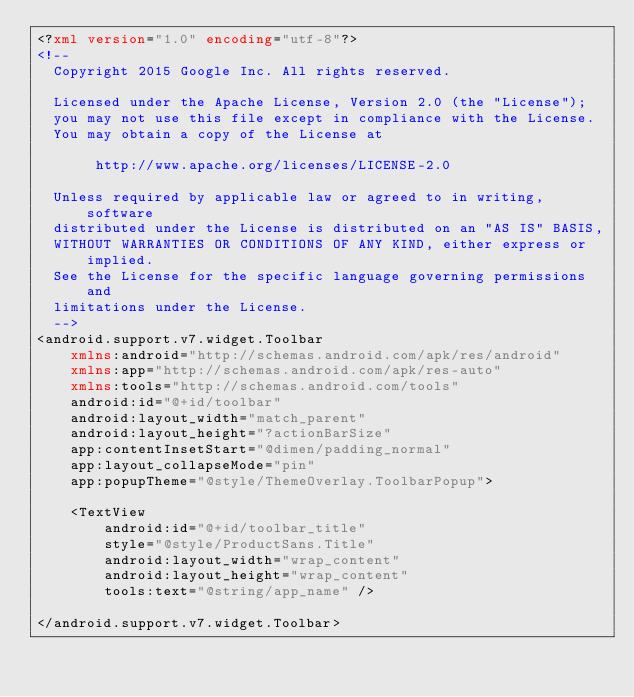Convert code to text. <code><loc_0><loc_0><loc_500><loc_500><_XML_><?xml version="1.0" encoding="utf-8"?>
<!--
  Copyright 2015 Google Inc. All rights reserved.

  Licensed under the Apache License, Version 2.0 (the "License");
  you may not use this file except in compliance with the License.
  You may obtain a copy of the License at

       http://www.apache.org/licenses/LICENSE-2.0

  Unless required by applicable law or agreed to in writing, software
  distributed under the License is distributed on an "AS IS" BASIS,
  WITHOUT WARRANTIES OR CONDITIONS OF ANY KIND, either express or implied.
  See the License for the specific language governing permissions and
  limitations under the License.
  -->
<android.support.v7.widget.Toolbar
    xmlns:android="http://schemas.android.com/apk/res/android"
    xmlns:app="http://schemas.android.com/apk/res-auto"
    xmlns:tools="http://schemas.android.com/tools"
    android:id="@+id/toolbar"
    android:layout_width="match_parent"
    android:layout_height="?actionBarSize"
    app:contentInsetStart="@dimen/padding_normal"
    app:layout_collapseMode="pin"
    app:popupTheme="@style/ThemeOverlay.ToolbarPopup">

    <TextView
        android:id="@+id/toolbar_title"
        style="@style/ProductSans.Title"
        android:layout_width="wrap_content"
        android:layout_height="wrap_content"
        tools:text="@string/app_name" />

</android.support.v7.widget.Toolbar>
</code> 